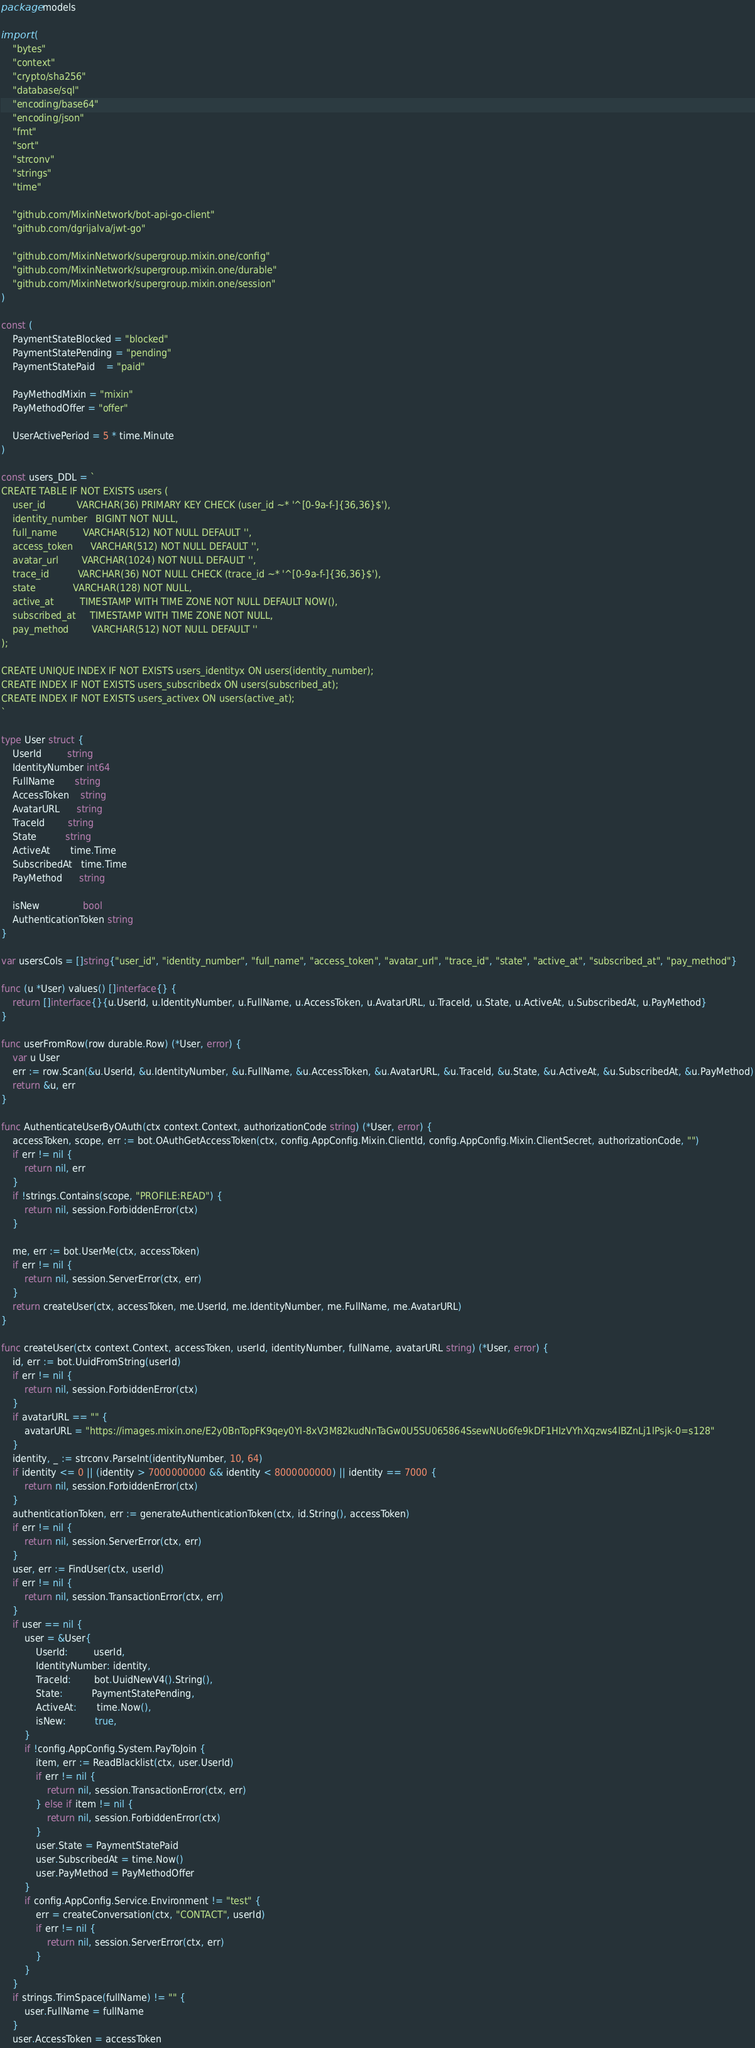Convert code to text. <code><loc_0><loc_0><loc_500><loc_500><_Go_>package models

import (
	"bytes"
	"context"
	"crypto/sha256"
	"database/sql"
	"encoding/base64"
	"encoding/json"
	"fmt"
	"sort"
	"strconv"
	"strings"
	"time"

	"github.com/MixinNetwork/bot-api-go-client"
	"github.com/dgrijalva/jwt-go"

	"github.com/MixinNetwork/supergroup.mixin.one/config"
	"github.com/MixinNetwork/supergroup.mixin.one/durable"
	"github.com/MixinNetwork/supergroup.mixin.one/session"
)

const (
	PaymentStateBlocked = "blocked"
	PaymentStatePending = "pending"
	PaymentStatePaid    = "paid"

	PayMethodMixin = "mixin"
	PayMethodOffer = "offer"

	UserActivePeriod = 5 * time.Minute
)

const users_DDL = `
CREATE TABLE IF NOT EXISTS users (
	user_id	          VARCHAR(36) PRIMARY KEY CHECK (user_id ~* '^[0-9a-f-]{36,36}$'),
	identity_number   BIGINT NOT NULL,
	full_name         VARCHAR(512) NOT NULL DEFAULT '',
	access_token      VARCHAR(512) NOT NULL DEFAULT '',
	avatar_url        VARCHAR(1024) NOT NULL DEFAULT '',
	trace_id          VARCHAR(36) NOT NULL CHECK (trace_id ~* '^[0-9a-f-]{36,36}$'),
	state             VARCHAR(128) NOT NULL,
	active_at         TIMESTAMP WITH TIME ZONE NOT NULL DEFAULT NOW(),
	subscribed_at     TIMESTAMP WITH TIME ZONE NOT NULL,
	pay_method        VARCHAR(512) NOT NULL DEFAULT ''
);

CREATE UNIQUE INDEX IF NOT EXISTS users_identityx ON users(identity_number);
CREATE INDEX IF NOT EXISTS users_subscribedx ON users(subscribed_at);
CREATE INDEX IF NOT EXISTS users_activex ON users(active_at);
`

type User struct {
	UserId         string
	IdentityNumber int64
	FullName       string
	AccessToken    string
	AvatarURL      string
	TraceId        string
	State          string
	ActiveAt       time.Time
	SubscribedAt   time.Time
	PayMethod      string

	isNew               bool
	AuthenticationToken string
}

var usersCols = []string{"user_id", "identity_number", "full_name", "access_token", "avatar_url", "trace_id", "state", "active_at", "subscribed_at", "pay_method"}

func (u *User) values() []interface{} {
	return []interface{}{u.UserId, u.IdentityNumber, u.FullName, u.AccessToken, u.AvatarURL, u.TraceId, u.State, u.ActiveAt, u.SubscribedAt, u.PayMethod}
}

func userFromRow(row durable.Row) (*User, error) {
	var u User
	err := row.Scan(&u.UserId, &u.IdentityNumber, &u.FullName, &u.AccessToken, &u.AvatarURL, &u.TraceId, &u.State, &u.ActiveAt, &u.SubscribedAt, &u.PayMethod)
	return &u, err
}

func AuthenticateUserByOAuth(ctx context.Context, authorizationCode string) (*User, error) {
	accessToken, scope, err := bot.OAuthGetAccessToken(ctx, config.AppConfig.Mixin.ClientId, config.AppConfig.Mixin.ClientSecret, authorizationCode, "")
	if err != nil {
		return nil, err
	}
	if !strings.Contains(scope, "PROFILE:READ") {
		return nil, session.ForbiddenError(ctx)
	}

	me, err := bot.UserMe(ctx, accessToken)
	if err != nil {
		return nil, session.ServerError(ctx, err)
	}
	return createUser(ctx, accessToken, me.UserId, me.IdentityNumber, me.FullName, me.AvatarURL)
}

func createUser(ctx context.Context, accessToken, userId, identityNumber, fullName, avatarURL string) (*User, error) {
	id, err := bot.UuidFromString(userId)
	if err != nil {
		return nil, session.ForbiddenError(ctx)
	}
	if avatarURL == "" {
		avatarURL = "https://images.mixin.one/E2y0BnTopFK9qey0YI-8xV3M82kudNnTaGw0U5SU065864SsewNUo6fe9kDF1HIzVYhXqzws4lBZnLj1lPsjk-0=s128"
	}
	identity, _ := strconv.ParseInt(identityNumber, 10, 64)
	if identity <= 0 || (identity > 7000000000 && identity < 8000000000) || identity == 7000 {
		return nil, session.ForbiddenError(ctx)
	}
	authenticationToken, err := generateAuthenticationToken(ctx, id.String(), accessToken)
	if err != nil {
		return nil, session.ServerError(ctx, err)
	}
	user, err := FindUser(ctx, userId)
	if err != nil {
		return nil, session.TransactionError(ctx, err)
	}
	if user == nil {
		user = &User{
			UserId:         userId,
			IdentityNumber: identity,
			TraceId:        bot.UuidNewV4().String(),
			State:          PaymentStatePending,
			ActiveAt:       time.Now(),
			isNew:          true,
		}
		if !config.AppConfig.System.PayToJoin {
			item, err := ReadBlacklist(ctx, user.UserId)
			if err != nil {
				return nil, session.TransactionError(ctx, err)
			} else if item != nil {
				return nil, session.ForbiddenError(ctx)
			}
			user.State = PaymentStatePaid
			user.SubscribedAt = time.Now()
			user.PayMethod = PayMethodOffer
		}
		if config.AppConfig.Service.Environment != "test" {
			err = createConversation(ctx, "CONTACT", userId)
			if err != nil {
				return nil, session.ServerError(ctx, err)
			}
		}
	}
	if strings.TrimSpace(fullName) != "" {
		user.FullName = fullName
	}
	user.AccessToken = accessToken</code> 